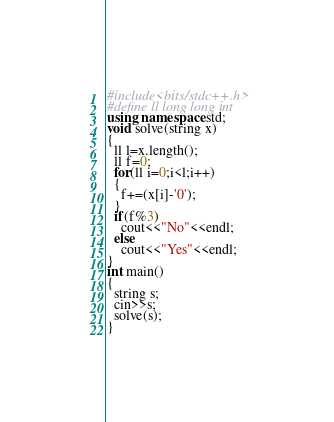<code> <loc_0><loc_0><loc_500><loc_500><_C++_>#include<bits/stdc++.h>
#define ll long long int
using namespace std;
void solve(string x)
{
  ll l=x.length();
  ll f=0;
  for(ll i=0;i<l;i++)
  {
    f+=(x[i]-'0');
  }
  if(f%3)
    cout<<"No"<<endl;
  else
    cout<<"Yes"<<endl;
}
int main()
{
  string s;
  cin>>s;
  solve(s);
}</code> 